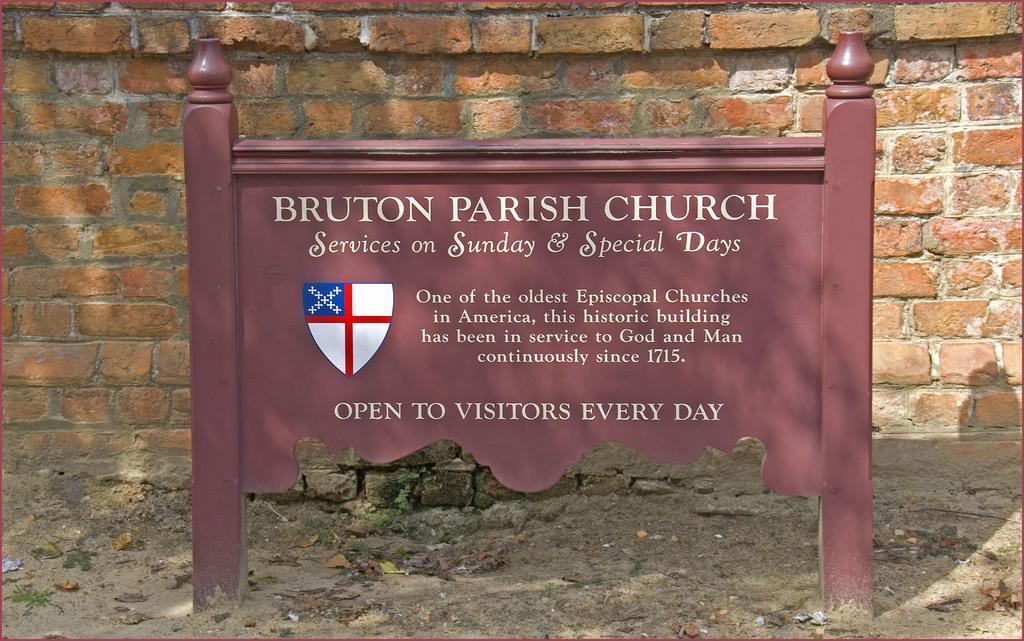Please provide a concise description of this image. In the center of the picture there is an iron board, on the board there is text. In the background we can see a brick wall. At the bottom there are dry leaves and soil. 